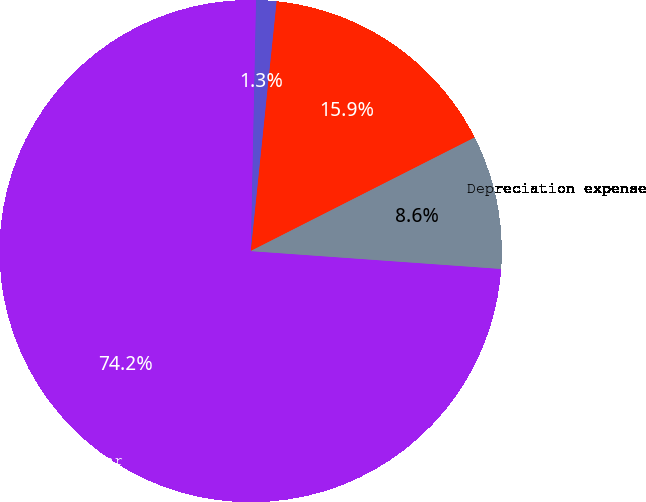Convert chart to OTSL. <chart><loc_0><loc_0><loc_500><loc_500><pie_chart><fcel>Acquisition of real state<fcel>Disposition of real estate<fcel>Balances at end of year<fcel>Depreciation expense<nl><fcel>15.89%<fcel>1.31%<fcel>74.2%<fcel>8.6%<nl></chart> 